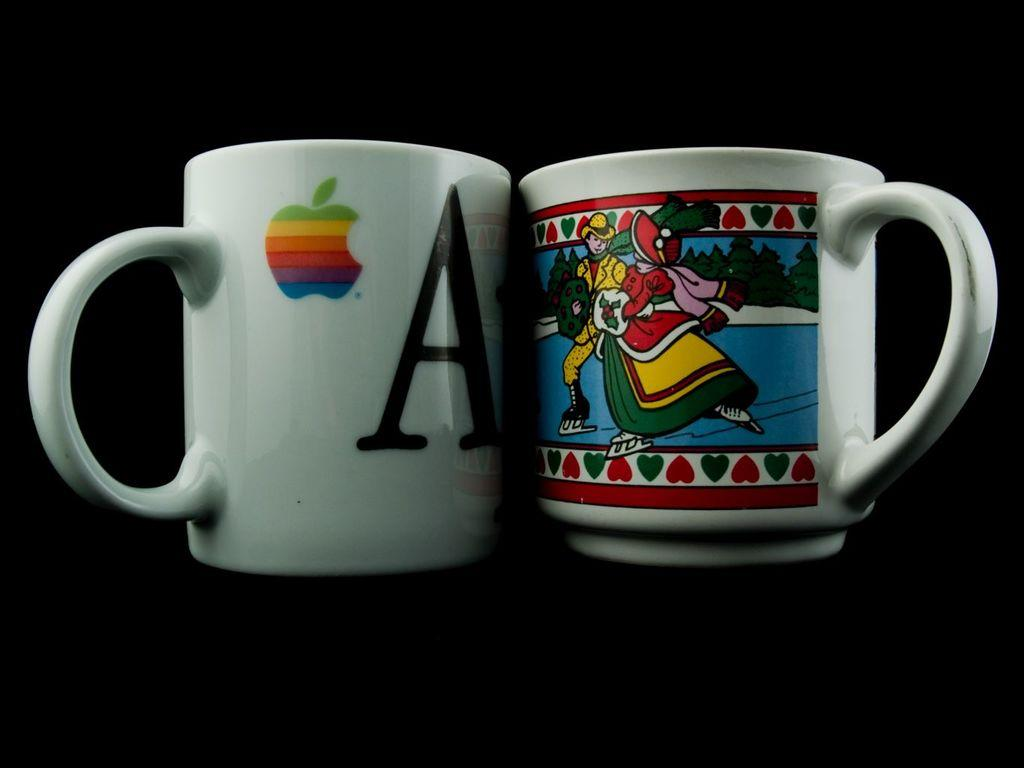<image>
Present a compact description of the photo's key features. Two white coffee mugs, one with the letter 'A' on it, the other with people skating outdoors. 